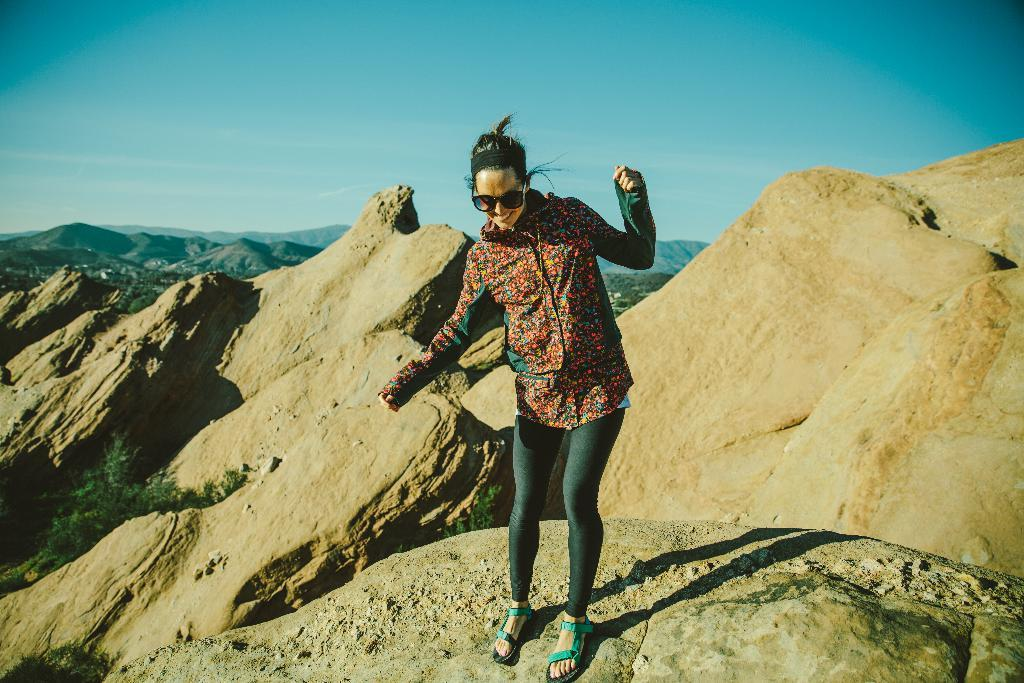Who is present in the image? There is a person in the image. What is the person wearing? The person is wearing a red shirt and gray pants. What can be seen in the background of the image? There are mountains visible in the background of the image. What is the color of the sky in the image? The sky is blue and white in color. Can you see any feathers floating in the air in the image? There are no feathers visible in the image. Is the person in the image using a skate to move around? There is no indication of a skate or any other form of transportation in the image. 